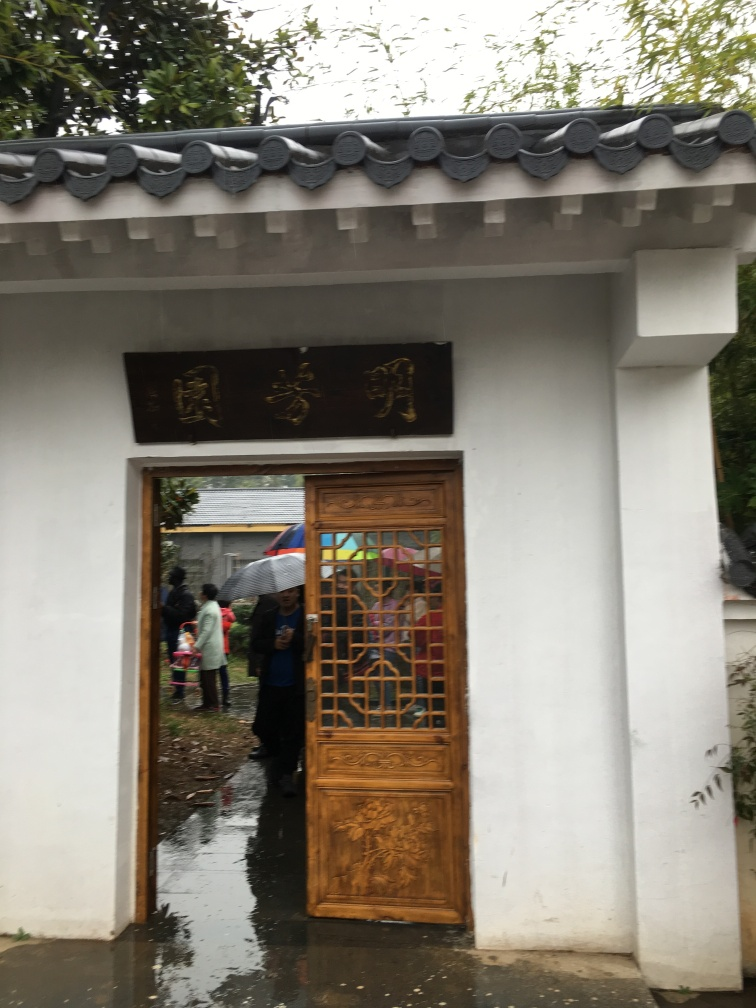What can you infer about the location depicted in the image? Judging by the traditional architectural elements and the Asian characters on the signboard above the door, this location likely is in East Asia, and the attire of the people suggests it is a contemporary setting. 